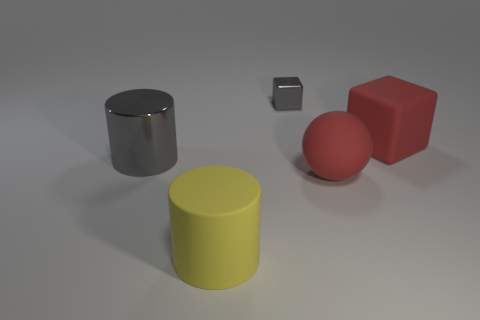The small gray shiny thing has what shape?
Offer a terse response. Cube. How many other things are the same material as the tiny gray cube?
Your response must be concise. 1. There is a big thing that is in front of the large red thing that is in front of the gray shiny object that is on the left side of the tiny metal block; what is its color?
Provide a short and direct response. Yellow. What is the material of the sphere that is the same size as the red matte cube?
Provide a succinct answer. Rubber. What number of things are small metallic cubes that are on the right side of the large shiny object or large yellow matte cylinders?
Offer a terse response. 2. Are there any spheres?
Offer a very short reply. Yes. There is a block that is on the right side of the small gray metal cube; what is its material?
Provide a succinct answer. Rubber. There is a large block that is the same color as the rubber sphere; what material is it?
Offer a very short reply. Rubber. How many large things are spheres or yellow matte objects?
Provide a short and direct response. 2. The tiny shiny object has what color?
Your answer should be very brief. Gray. 